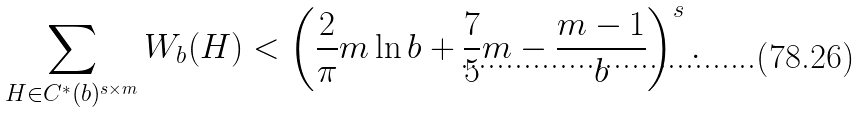Convert formula to latex. <formula><loc_0><loc_0><loc_500><loc_500>\sum _ { H \in C ^ { * } ( b ) ^ { s \times m } } W _ { b } ( H ) < \left ( \frac { 2 } { \pi } m \ln b + \frac { 7 } { 5 } m - \frac { m - 1 } { b } \right ) ^ { s } .</formula> 